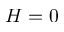Convert formula to latex. <formula><loc_0><loc_0><loc_500><loc_500>H = 0</formula> 